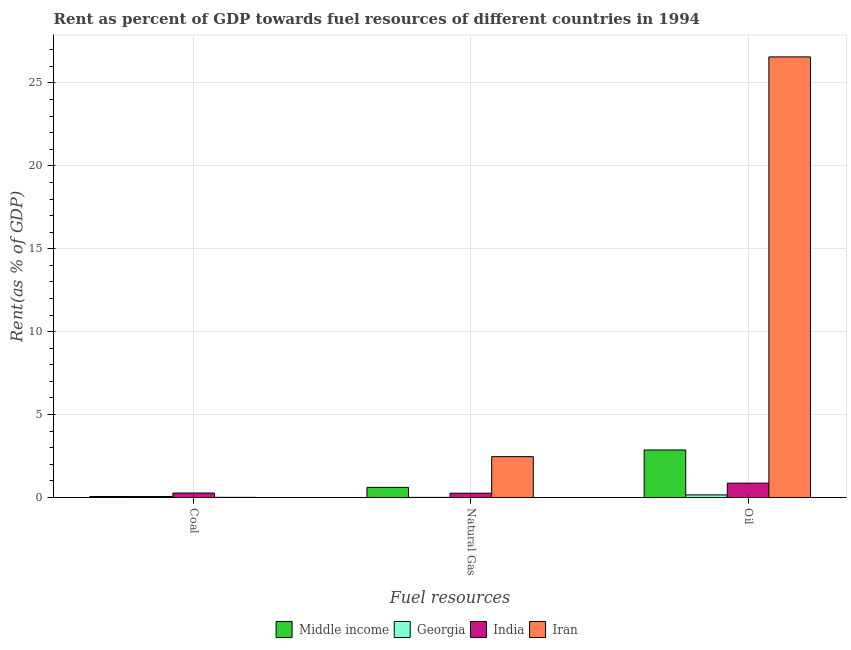How many different coloured bars are there?
Ensure brevity in your answer.  4. How many groups of bars are there?
Offer a terse response. 3. Are the number of bars per tick equal to the number of legend labels?
Give a very brief answer. Yes. How many bars are there on the 3rd tick from the left?
Offer a terse response. 4. What is the label of the 3rd group of bars from the left?
Give a very brief answer. Oil. What is the rent towards oil in Middle income?
Offer a terse response. 2.87. Across all countries, what is the maximum rent towards oil?
Your answer should be compact. 26.57. Across all countries, what is the minimum rent towards natural gas?
Keep it short and to the point. 0.01. In which country was the rent towards oil maximum?
Offer a very short reply. Iran. In which country was the rent towards natural gas minimum?
Offer a very short reply. Georgia. What is the total rent towards natural gas in the graph?
Give a very brief answer. 3.34. What is the difference between the rent towards coal in India and that in Iran?
Offer a very short reply. 0.26. What is the difference between the rent towards oil in Iran and the rent towards natural gas in Middle income?
Offer a terse response. 25.96. What is the average rent towards coal per country?
Make the answer very short. 0.1. What is the difference between the rent towards coal and rent towards oil in Middle income?
Your response must be concise. -2.81. What is the ratio of the rent towards coal in India to that in Middle income?
Your answer should be compact. 4.69. What is the difference between the highest and the second highest rent towards natural gas?
Ensure brevity in your answer.  1.85. What is the difference between the highest and the lowest rent towards coal?
Your answer should be compact. 0.26. In how many countries, is the rent towards natural gas greater than the average rent towards natural gas taken over all countries?
Your answer should be very brief. 1. Is the sum of the rent towards oil in India and Georgia greater than the maximum rent towards natural gas across all countries?
Your response must be concise. No. What does the 2nd bar from the left in Natural Gas represents?
Provide a short and direct response. Georgia. What does the 1st bar from the right in Coal represents?
Offer a very short reply. Iran. How many bars are there?
Keep it short and to the point. 12. Are all the bars in the graph horizontal?
Keep it short and to the point. No. What is the difference between two consecutive major ticks on the Y-axis?
Your answer should be very brief. 5. Does the graph contain grids?
Ensure brevity in your answer.  Yes. Where does the legend appear in the graph?
Your answer should be very brief. Bottom center. How many legend labels are there?
Keep it short and to the point. 4. What is the title of the graph?
Give a very brief answer. Rent as percent of GDP towards fuel resources of different countries in 1994. Does "Equatorial Guinea" appear as one of the legend labels in the graph?
Your response must be concise. No. What is the label or title of the X-axis?
Give a very brief answer. Fuel resources. What is the label or title of the Y-axis?
Ensure brevity in your answer.  Rent(as % of GDP). What is the Rent(as % of GDP) of Middle income in Coal?
Your answer should be very brief. 0.06. What is the Rent(as % of GDP) in Georgia in Coal?
Ensure brevity in your answer.  0.06. What is the Rent(as % of GDP) in India in Coal?
Your answer should be compact. 0.27. What is the Rent(as % of GDP) in Iran in Coal?
Make the answer very short. 0.01. What is the Rent(as % of GDP) in Middle income in Natural Gas?
Make the answer very short. 0.61. What is the Rent(as % of GDP) of Georgia in Natural Gas?
Provide a succinct answer. 0.01. What is the Rent(as % of GDP) of India in Natural Gas?
Your answer should be very brief. 0.26. What is the Rent(as % of GDP) in Iran in Natural Gas?
Offer a very short reply. 2.46. What is the Rent(as % of GDP) in Middle income in Oil?
Your answer should be compact. 2.87. What is the Rent(as % of GDP) in Georgia in Oil?
Your answer should be very brief. 0.16. What is the Rent(as % of GDP) of India in Oil?
Your response must be concise. 0.86. What is the Rent(as % of GDP) of Iran in Oil?
Your answer should be compact. 26.57. Across all Fuel resources, what is the maximum Rent(as % of GDP) in Middle income?
Give a very brief answer. 2.87. Across all Fuel resources, what is the maximum Rent(as % of GDP) in Georgia?
Ensure brevity in your answer.  0.16. Across all Fuel resources, what is the maximum Rent(as % of GDP) in India?
Make the answer very short. 0.86. Across all Fuel resources, what is the maximum Rent(as % of GDP) of Iran?
Give a very brief answer. 26.57. Across all Fuel resources, what is the minimum Rent(as % of GDP) in Middle income?
Provide a succinct answer. 0.06. Across all Fuel resources, what is the minimum Rent(as % of GDP) in Georgia?
Keep it short and to the point. 0.01. Across all Fuel resources, what is the minimum Rent(as % of GDP) in India?
Your answer should be compact. 0.26. Across all Fuel resources, what is the minimum Rent(as % of GDP) of Iran?
Ensure brevity in your answer.  0.01. What is the total Rent(as % of GDP) of Middle income in the graph?
Your response must be concise. 3.53. What is the total Rent(as % of GDP) of Georgia in the graph?
Offer a terse response. 0.22. What is the total Rent(as % of GDP) of India in the graph?
Offer a terse response. 1.39. What is the total Rent(as % of GDP) in Iran in the graph?
Offer a very short reply. 29.04. What is the difference between the Rent(as % of GDP) in Middle income in Coal and that in Natural Gas?
Provide a succinct answer. -0.55. What is the difference between the Rent(as % of GDP) in Georgia in Coal and that in Natural Gas?
Make the answer very short. 0.05. What is the difference between the Rent(as % of GDP) of India in Coal and that in Natural Gas?
Offer a very short reply. 0.01. What is the difference between the Rent(as % of GDP) of Iran in Coal and that in Natural Gas?
Give a very brief answer. -2.46. What is the difference between the Rent(as % of GDP) in Middle income in Coal and that in Oil?
Your response must be concise. -2.81. What is the difference between the Rent(as % of GDP) of Georgia in Coal and that in Oil?
Ensure brevity in your answer.  -0.1. What is the difference between the Rent(as % of GDP) of India in Coal and that in Oil?
Ensure brevity in your answer.  -0.6. What is the difference between the Rent(as % of GDP) of Iran in Coal and that in Oil?
Ensure brevity in your answer.  -26.56. What is the difference between the Rent(as % of GDP) of Middle income in Natural Gas and that in Oil?
Offer a very short reply. -2.26. What is the difference between the Rent(as % of GDP) of Georgia in Natural Gas and that in Oil?
Your answer should be compact. -0.15. What is the difference between the Rent(as % of GDP) of India in Natural Gas and that in Oil?
Your response must be concise. -0.61. What is the difference between the Rent(as % of GDP) in Iran in Natural Gas and that in Oil?
Provide a short and direct response. -24.11. What is the difference between the Rent(as % of GDP) in Middle income in Coal and the Rent(as % of GDP) in Georgia in Natural Gas?
Offer a very short reply. 0.05. What is the difference between the Rent(as % of GDP) in Middle income in Coal and the Rent(as % of GDP) in India in Natural Gas?
Offer a very short reply. -0.2. What is the difference between the Rent(as % of GDP) of Middle income in Coal and the Rent(as % of GDP) of Iran in Natural Gas?
Provide a short and direct response. -2.41. What is the difference between the Rent(as % of GDP) of Georgia in Coal and the Rent(as % of GDP) of India in Natural Gas?
Offer a terse response. -0.2. What is the difference between the Rent(as % of GDP) in Georgia in Coal and the Rent(as % of GDP) in Iran in Natural Gas?
Offer a terse response. -2.41. What is the difference between the Rent(as % of GDP) of India in Coal and the Rent(as % of GDP) of Iran in Natural Gas?
Provide a short and direct response. -2.19. What is the difference between the Rent(as % of GDP) of Middle income in Coal and the Rent(as % of GDP) of Georgia in Oil?
Your response must be concise. -0.1. What is the difference between the Rent(as % of GDP) of Middle income in Coal and the Rent(as % of GDP) of India in Oil?
Your answer should be very brief. -0.81. What is the difference between the Rent(as % of GDP) in Middle income in Coal and the Rent(as % of GDP) in Iran in Oil?
Keep it short and to the point. -26.51. What is the difference between the Rent(as % of GDP) in Georgia in Coal and the Rent(as % of GDP) in India in Oil?
Provide a succinct answer. -0.81. What is the difference between the Rent(as % of GDP) in Georgia in Coal and the Rent(as % of GDP) in Iran in Oil?
Keep it short and to the point. -26.51. What is the difference between the Rent(as % of GDP) of India in Coal and the Rent(as % of GDP) of Iran in Oil?
Offer a terse response. -26.3. What is the difference between the Rent(as % of GDP) of Middle income in Natural Gas and the Rent(as % of GDP) of Georgia in Oil?
Offer a very short reply. 0.45. What is the difference between the Rent(as % of GDP) of Middle income in Natural Gas and the Rent(as % of GDP) of India in Oil?
Offer a terse response. -0.26. What is the difference between the Rent(as % of GDP) in Middle income in Natural Gas and the Rent(as % of GDP) in Iran in Oil?
Give a very brief answer. -25.96. What is the difference between the Rent(as % of GDP) of Georgia in Natural Gas and the Rent(as % of GDP) of India in Oil?
Provide a succinct answer. -0.86. What is the difference between the Rent(as % of GDP) in Georgia in Natural Gas and the Rent(as % of GDP) in Iran in Oil?
Keep it short and to the point. -26.56. What is the difference between the Rent(as % of GDP) of India in Natural Gas and the Rent(as % of GDP) of Iran in Oil?
Your answer should be very brief. -26.31. What is the average Rent(as % of GDP) of Middle income per Fuel resources?
Your response must be concise. 1.18. What is the average Rent(as % of GDP) of Georgia per Fuel resources?
Ensure brevity in your answer.  0.07. What is the average Rent(as % of GDP) of India per Fuel resources?
Make the answer very short. 0.46. What is the average Rent(as % of GDP) of Iran per Fuel resources?
Provide a short and direct response. 9.68. What is the difference between the Rent(as % of GDP) in Middle income and Rent(as % of GDP) in Georgia in Coal?
Your answer should be very brief. 0. What is the difference between the Rent(as % of GDP) of Middle income and Rent(as % of GDP) of India in Coal?
Your response must be concise. -0.21. What is the difference between the Rent(as % of GDP) of Middle income and Rent(as % of GDP) of Iran in Coal?
Your answer should be very brief. 0.05. What is the difference between the Rent(as % of GDP) in Georgia and Rent(as % of GDP) in India in Coal?
Make the answer very short. -0.21. What is the difference between the Rent(as % of GDP) of Georgia and Rent(as % of GDP) of Iran in Coal?
Your answer should be compact. 0.05. What is the difference between the Rent(as % of GDP) in India and Rent(as % of GDP) in Iran in Coal?
Offer a very short reply. 0.26. What is the difference between the Rent(as % of GDP) in Middle income and Rent(as % of GDP) in Georgia in Natural Gas?
Make the answer very short. 0.6. What is the difference between the Rent(as % of GDP) of Middle income and Rent(as % of GDP) of India in Natural Gas?
Offer a terse response. 0.35. What is the difference between the Rent(as % of GDP) in Middle income and Rent(as % of GDP) in Iran in Natural Gas?
Offer a terse response. -1.85. What is the difference between the Rent(as % of GDP) in Georgia and Rent(as % of GDP) in India in Natural Gas?
Your answer should be compact. -0.25. What is the difference between the Rent(as % of GDP) of Georgia and Rent(as % of GDP) of Iran in Natural Gas?
Give a very brief answer. -2.46. What is the difference between the Rent(as % of GDP) in India and Rent(as % of GDP) in Iran in Natural Gas?
Offer a terse response. -2.2. What is the difference between the Rent(as % of GDP) of Middle income and Rent(as % of GDP) of Georgia in Oil?
Your response must be concise. 2.71. What is the difference between the Rent(as % of GDP) in Middle income and Rent(as % of GDP) in India in Oil?
Your answer should be very brief. 2. What is the difference between the Rent(as % of GDP) in Middle income and Rent(as % of GDP) in Iran in Oil?
Your response must be concise. -23.7. What is the difference between the Rent(as % of GDP) of Georgia and Rent(as % of GDP) of India in Oil?
Your answer should be compact. -0.71. What is the difference between the Rent(as % of GDP) of Georgia and Rent(as % of GDP) of Iran in Oil?
Keep it short and to the point. -26.41. What is the difference between the Rent(as % of GDP) in India and Rent(as % of GDP) in Iran in Oil?
Give a very brief answer. -25.71. What is the ratio of the Rent(as % of GDP) in Middle income in Coal to that in Natural Gas?
Your answer should be compact. 0.09. What is the ratio of the Rent(as % of GDP) in Georgia in Coal to that in Natural Gas?
Your answer should be compact. 10.71. What is the ratio of the Rent(as % of GDP) in India in Coal to that in Natural Gas?
Your answer should be very brief. 1.04. What is the ratio of the Rent(as % of GDP) in Iran in Coal to that in Natural Gas?
Provide a short and direct response. 0. What is the ratio of the Rent(as % of GDP) of Middle income in Coal to that in Oil?
Your answer should be very brief. 0.02. What is the ratio of the Rent(as % of GDP) of Georgia in Coal to that in Oil?
Give a very brief answer. 0.36. What is the ratio of the Rent(as % of GDP) of India in Coal to that in Oil?
Your answer should be very brief. 0.31. What is the ratio of the Rent(as % of GDP) of Middle income in Natural Gas to that in Oil?
Provide a short and direct response. 0.21. What is the ratio of the Rent(as % of GDP) of Georgia in Natural Gas to that in Oil?
Give a very brief answer. 0.03. What is the ratio of the Rent(as % of GDP) of India in Natural Gas to that in Oil?
Give a very brief answer. 0.3. What is the ratio of the Rent(as % of GDP) of Iran in Natural Gas to that in Oil?
Make the answer very short. 0.09. What is the difference between the highest and the second highest Rent(as % of GDP) of Middle income?
Provide a succinct answer. 2.26. What is the difference between the highest and the second highest Rent(as % of GDP) of Georgia?
Provide a succinct answer. 0.1. What is the difference between the highest and the second highest Rent(as % of GDP) in India?
Provide a short and direct response. 0.6. What is the difference between the highest and the second highest Rent(as % of GDP) in Iran?
Offer a terse response. 24.11. What is the difference between the highest and the lowest Rent(as % of GDP) in Middle income?
Your answer should be very brief. 2.81. What is the difference between the highest and the lowest Rent(as % of GDP) of Georgia?
Provide a short and direct response. 0.15. What is the difference between the highest and the lowest Rent(as % of GDP) of India?
Give a very brief answer. 0.61. What is the difference between the highest and the lowest Rent(as % of GDP) of Iran?
Ensure brevity in your answer.  26.56. 